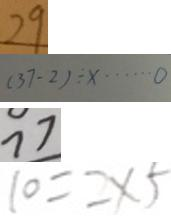Convert formula to latex. <formula><loc_0><loc_0><loc_500><loc_500>2 9 
 ( 3 7 - 2 ) \div x \cdots 0 
 7 7 
 1 0 = 2 \times 5</formula> 